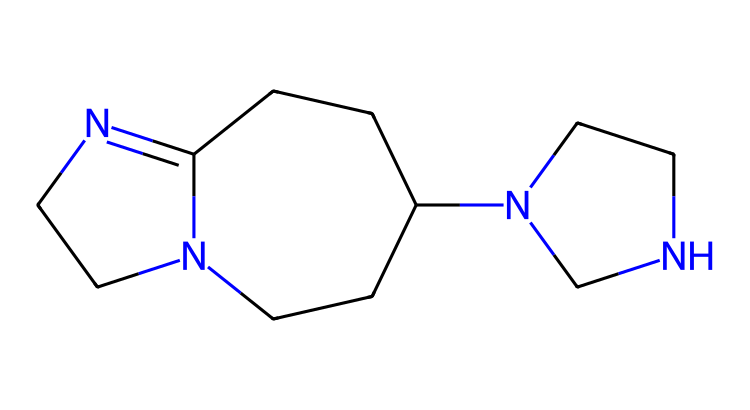What is the name of this chemical? The provided SMILES representation encodes the structure of 1,5,7-triazabicyclo[4.4.0]dec-5-ene, which is a well-known organocatalyst.
Answer: 1,5,7-triazabicyclo[4.4.0]dec-5-ene How many nitrogen atoms are present in this molecule? By analyzing the structure from the SMILES, we can identify three nitrogen atoms represented by "N" in the formula.
Answer: 3 What is the main function of this organocatalyst? 1,5,7-triazabicyclo[4.4.0]dec-5-ene (TBD) primarily acts as a superbasic organocatalyst, facilitating nucleophilic reactions through its high basicity.
Answer: superbasic organocatalyst How many rings are there in the molecular structure? The chemical structure indicates a bicyclic system as shown by the notation [4.4.0], which implies two rings in the bicyclic arrangement.
Answer: 2 What property makes TBD a superbase? The presence of nitrogen atoms, specifically the unique arrangement of these atoms that contributes to its electron-donating ability, leads to TBD's classification as a superbase.
Answer: electron-donating ability What is the molecular formula corresponding to this structure? By interpreting the SMILES representation, we can determine the molecular formula, which includes counting the atoms to yield C8H14N4.
Answer: C8H14N4 What type of reactions is TBD commonly used in? Due to its strong basicity and ability to activate electrophiles, TBD is commonly used in reactions such as deprotonation and catalyzing various organic transformations.
Answer: deprotonation and catalyzing organic transformations 